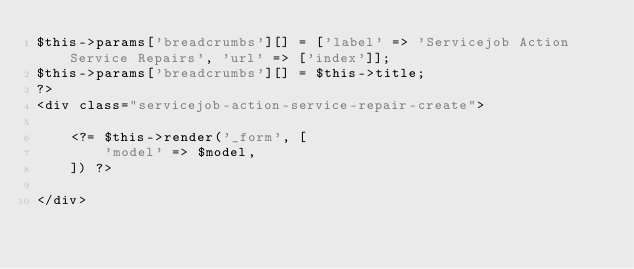Convert code to text. <code><loc_0><loc_0><loc_500><loc_500><_PHP_>$this->params['breadcrumbs'][] = ['label' => 'Servicejob Action Service Repairs', 'url' => ['index']];
$this->params['breadcrumbs'][] = $this->title;
?>
<div class="servicejob-action-service-repair-create">

    <?= $this->render('_form', [
        'model' => $model,
    ]) ?>

</div>
</code> 